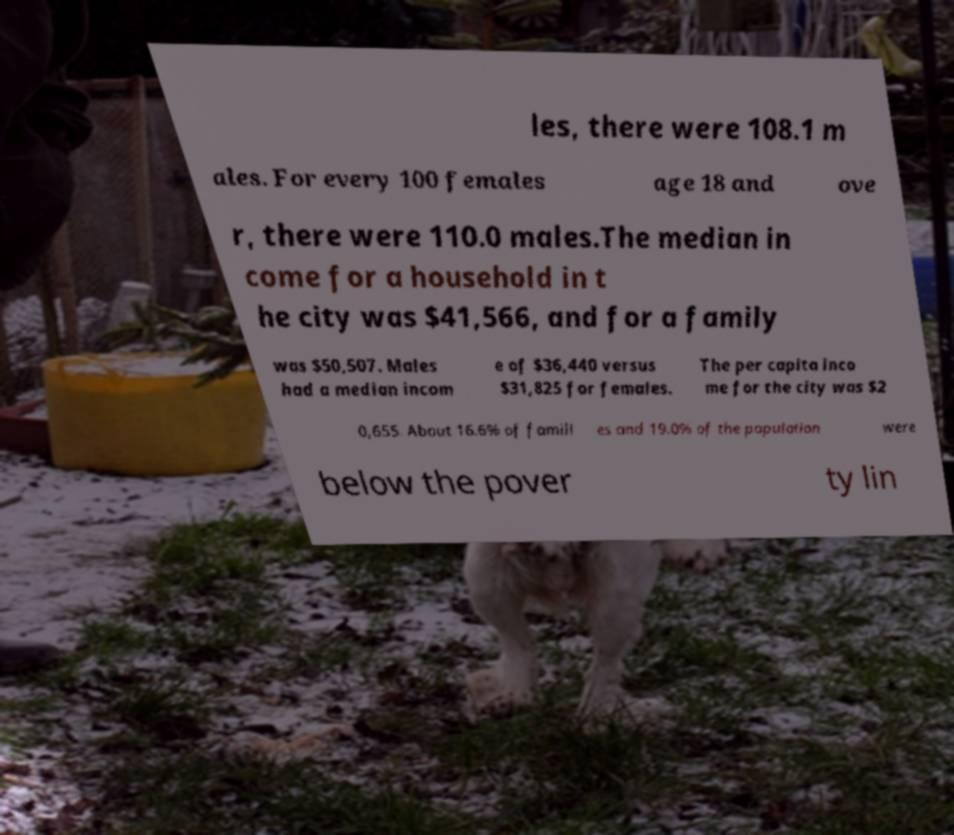Can you accurately transcribe the text from the provided image for me? les, there were 108.1 m ales. For every 100 females age 18 and ove r, there were 110.0 males.The median in come for a household in t he city was $41,566, and for a family was $50,507. Males had a median incom e of $36,440 versus $31,825 for females. The per capita inco me for the city was $2 0,655. About 16.6% of famili es and 19.0% of the population were below the pover ty lin 